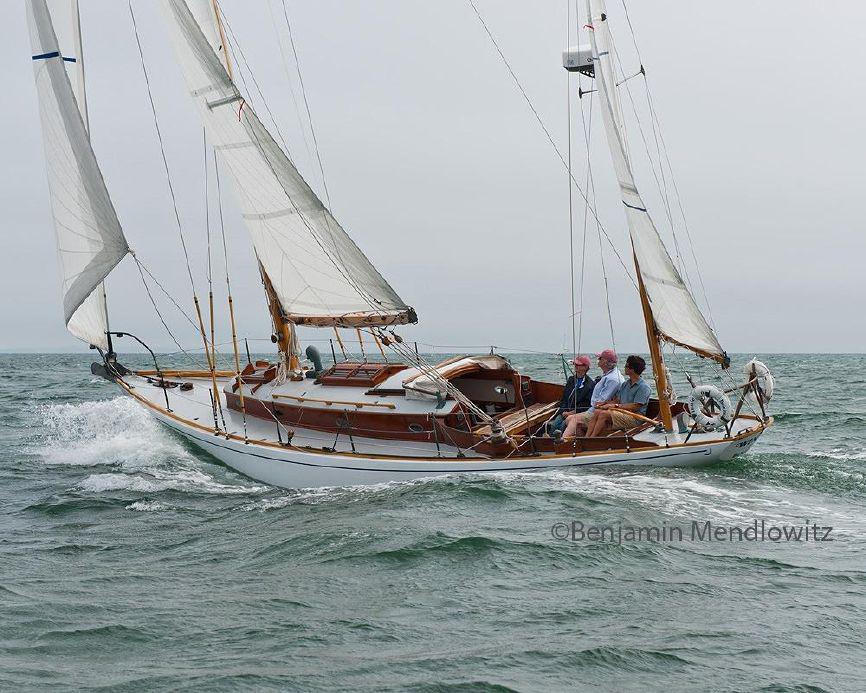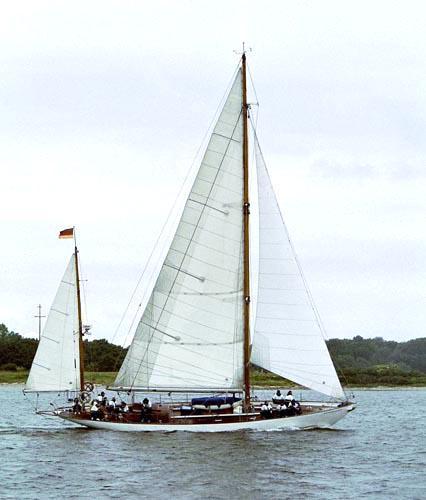The first image is the image on the left, the second image is the image on the right. Assess this claim about the two images: "White sea spray surrounds the boat in one of the images.". Correct or not? Answer yes or no. Yes. 